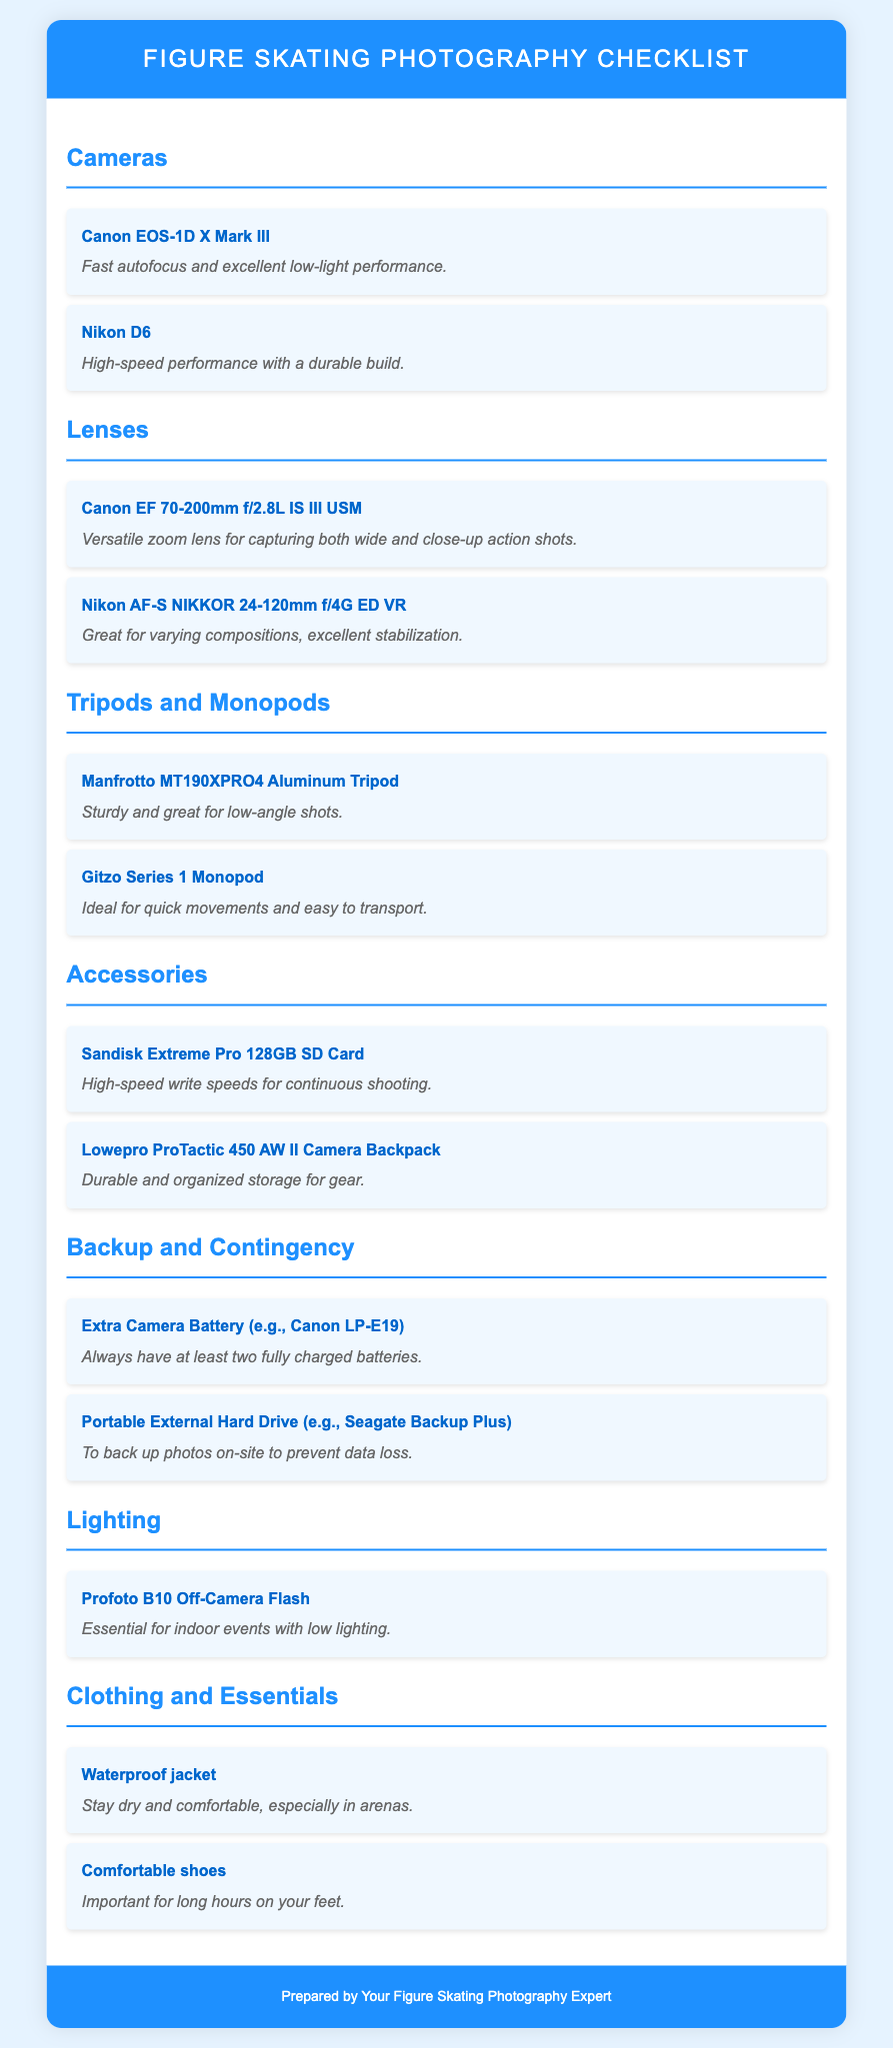what is the first camera listed? The first camera listed is the Canon EOS-1D X Mark III, which is noted for its fast autofocus and excellent low-light performance.
Answer: Canon EOS-1D X Mark III how many lenses are mentioned in the document? The document lists a total of two lenses available for figure skating photography.
Answer: 2 what is the item located under Backup and Contingency for data loss? The item listed for data loss prevention under Backup and Contingency is a Portable External Hard Drive.
Answer: Portable External Hard Drive which tripod is recommended for low-angle shots? The recommended tripod for low-angle shots is the Manfrotto MT190XPRO4 Aluminum Tripod.
Answer: Manfrotto MT190XPRO4 Aluminum Tripod what essential item is needed for indoor events with low lighting? The essential item needed for indoor events with low lighting is the Profoto B10 Off-Camera Flash.
Answer: Profoto B10 Off-Camera Flash what type of clothing is advised to stay dry in arenas? A Waterproof jacket is advised to stay dry and comfortable in arenas.
Answer: Waterproof jacket what brand is the recommended camera backpack? The recommended camera backpack is from Lowepro.
Answer: Lowepro which lens is noted for excellent stabilization? The Nikon AF-S NIKKOR 24-120mm f/4G ED VR lens is noted for its excellent stabilization.
Answer: Nikon AF-S NIKKOR 24-120mm f/4G ED VR 